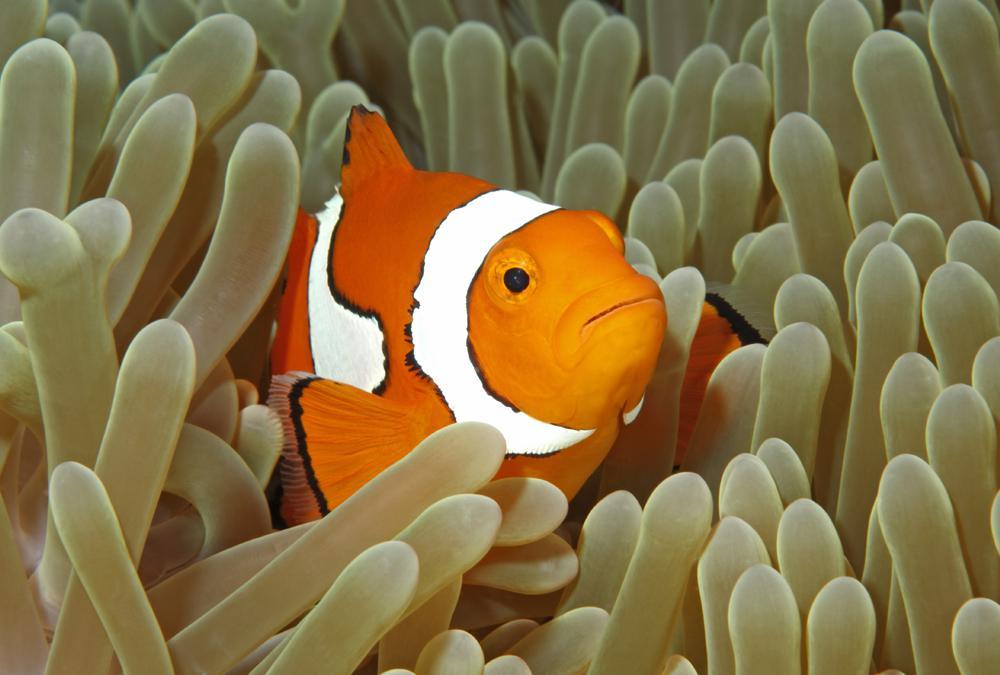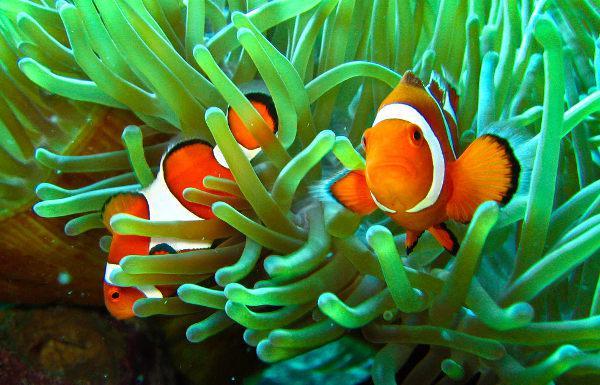The first image is the image on the left, the second image is the image on the right. For the images shown, is this caption "Both images show mainly similar-shaped orange-and-white striped fish swimming among anemone tendrils." true? Answer yes or no. Yes. The first image is the image on the left, the second image is the image on the right. Given the left and right images, does the statement "There are various species of fish in one of the images." hold true? Answer yes or no. No. 